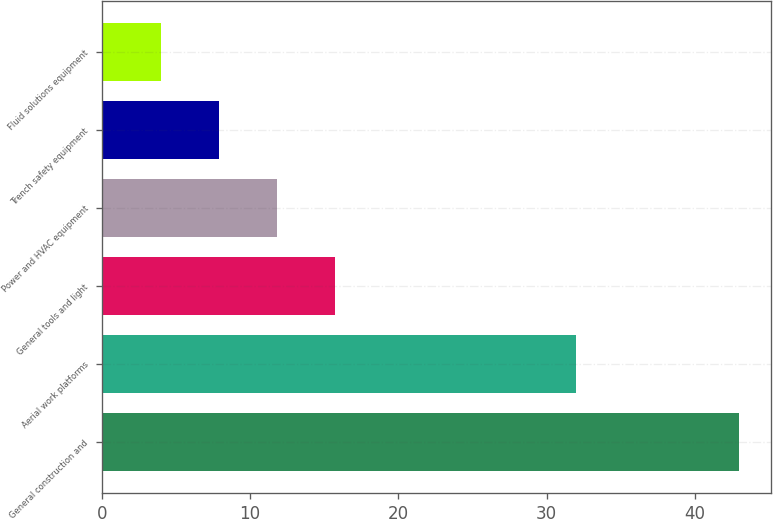Convert chart to OTSL. <chart><loc_0><loc_0><loc_500><loc_500><bar_chart><fcel>General construction and<fcel>Aerial work platforms<fcel>General tools and light<fcel>Power and HVAC equipment<fcel>Trench safety equipment<fcel>Fluid solutions equipment<nl><fcel>43<fcel>32<fcel>15.7<fcel>11.8<fcel>7.9<fcel>4<nl></chart> 